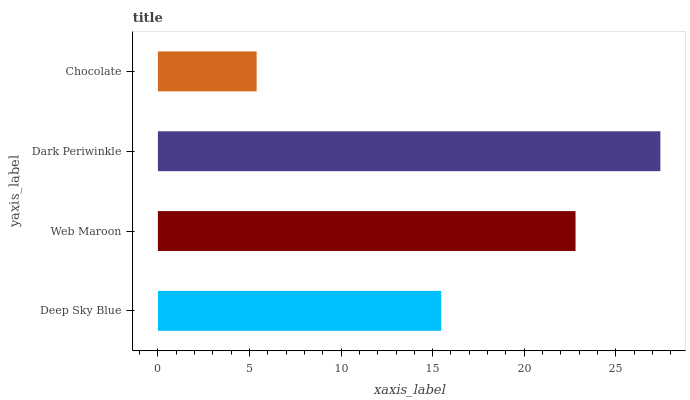Is Chocolate the minimum?
Answer yes or no. Yes. Is Dark Periwinkle the maximum?
Answer yes or no. Yes. Is Web Maroon the minimum?
Answer yes or no. No. Is Web Maroon the maximum?
Answer yes or no. No. Is Web Maroon greater than Deep Sky Blue?
Answer yes or no. Yes. Is Deep Sky Blue less than Web Maroon?
Answer yes or no. Yes. Is Deep Sky Blue greater than Web Maroon?
Answer yes or no. No. Is Web Maroon less than Deep Sky Blue?
Answer yes or no. No. Is Web Maroon the high median?
Answer yes or no. Yes. Is Deep Sky Blue the low median?
Answer yes or no. Yes. Is Chocolate the high median?
Answer yes or no. No. Is Web Maroon the low median?
Answer yes or no. No. 